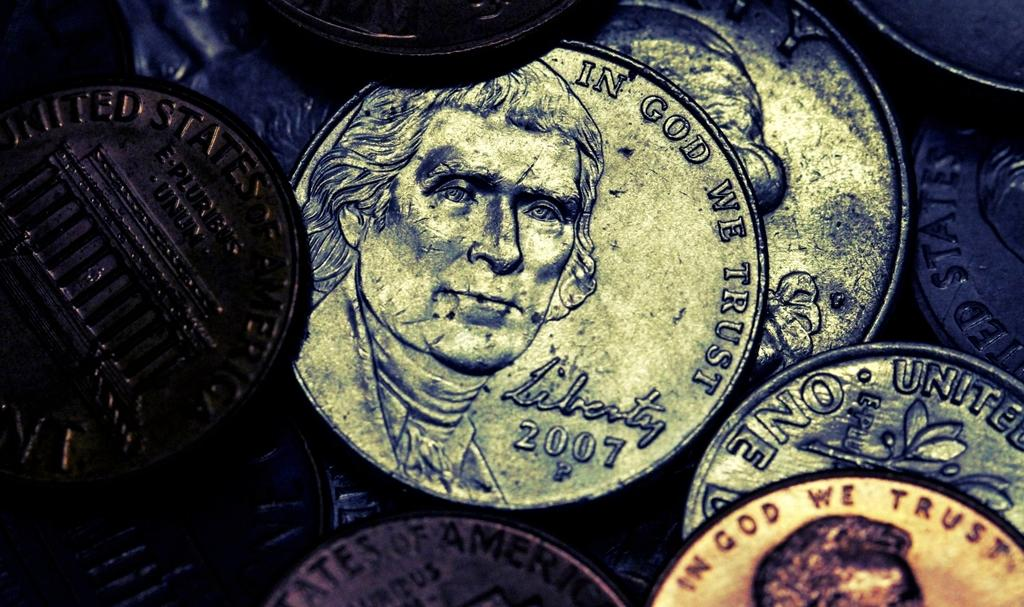Provide a one-sentence caption for the provided image. Some coins with In God We Trust written around the edge. 